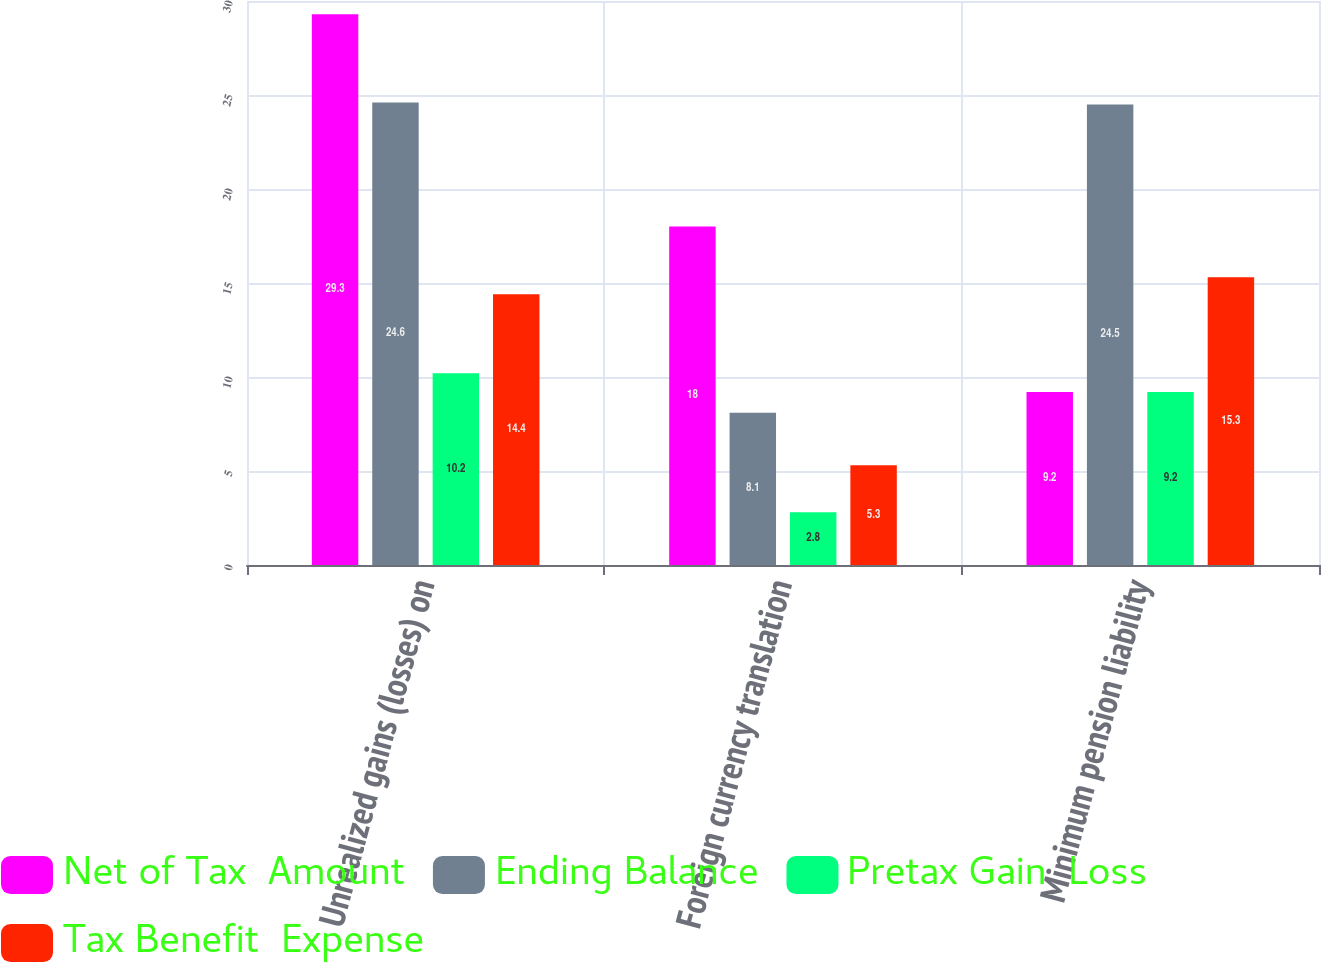Convert chart. <chart><loc_0><loc_0><loc_500><loc_500><stacked_bar_chart><ecel><fcel>Unrealized gains (losses) on<fcel>Foreign currency translation<fcel>Minimum pension liability<nl><fcel>Net of Tax  Amount<fcel>29.3<fcel>18<fcel>9.2<nl><fcel>Ending Balance<fcel>24.6<fcel>8.1<fcel>24.5<nl><fcel>Pretax Gain  Loss<fcel>10.2<fcel>2.8<fcel>9.2<nl><fcel>Tax Benefit  Expense<fcel>14.4<fcel>5.3<fcel>15.3<nl></chart> 